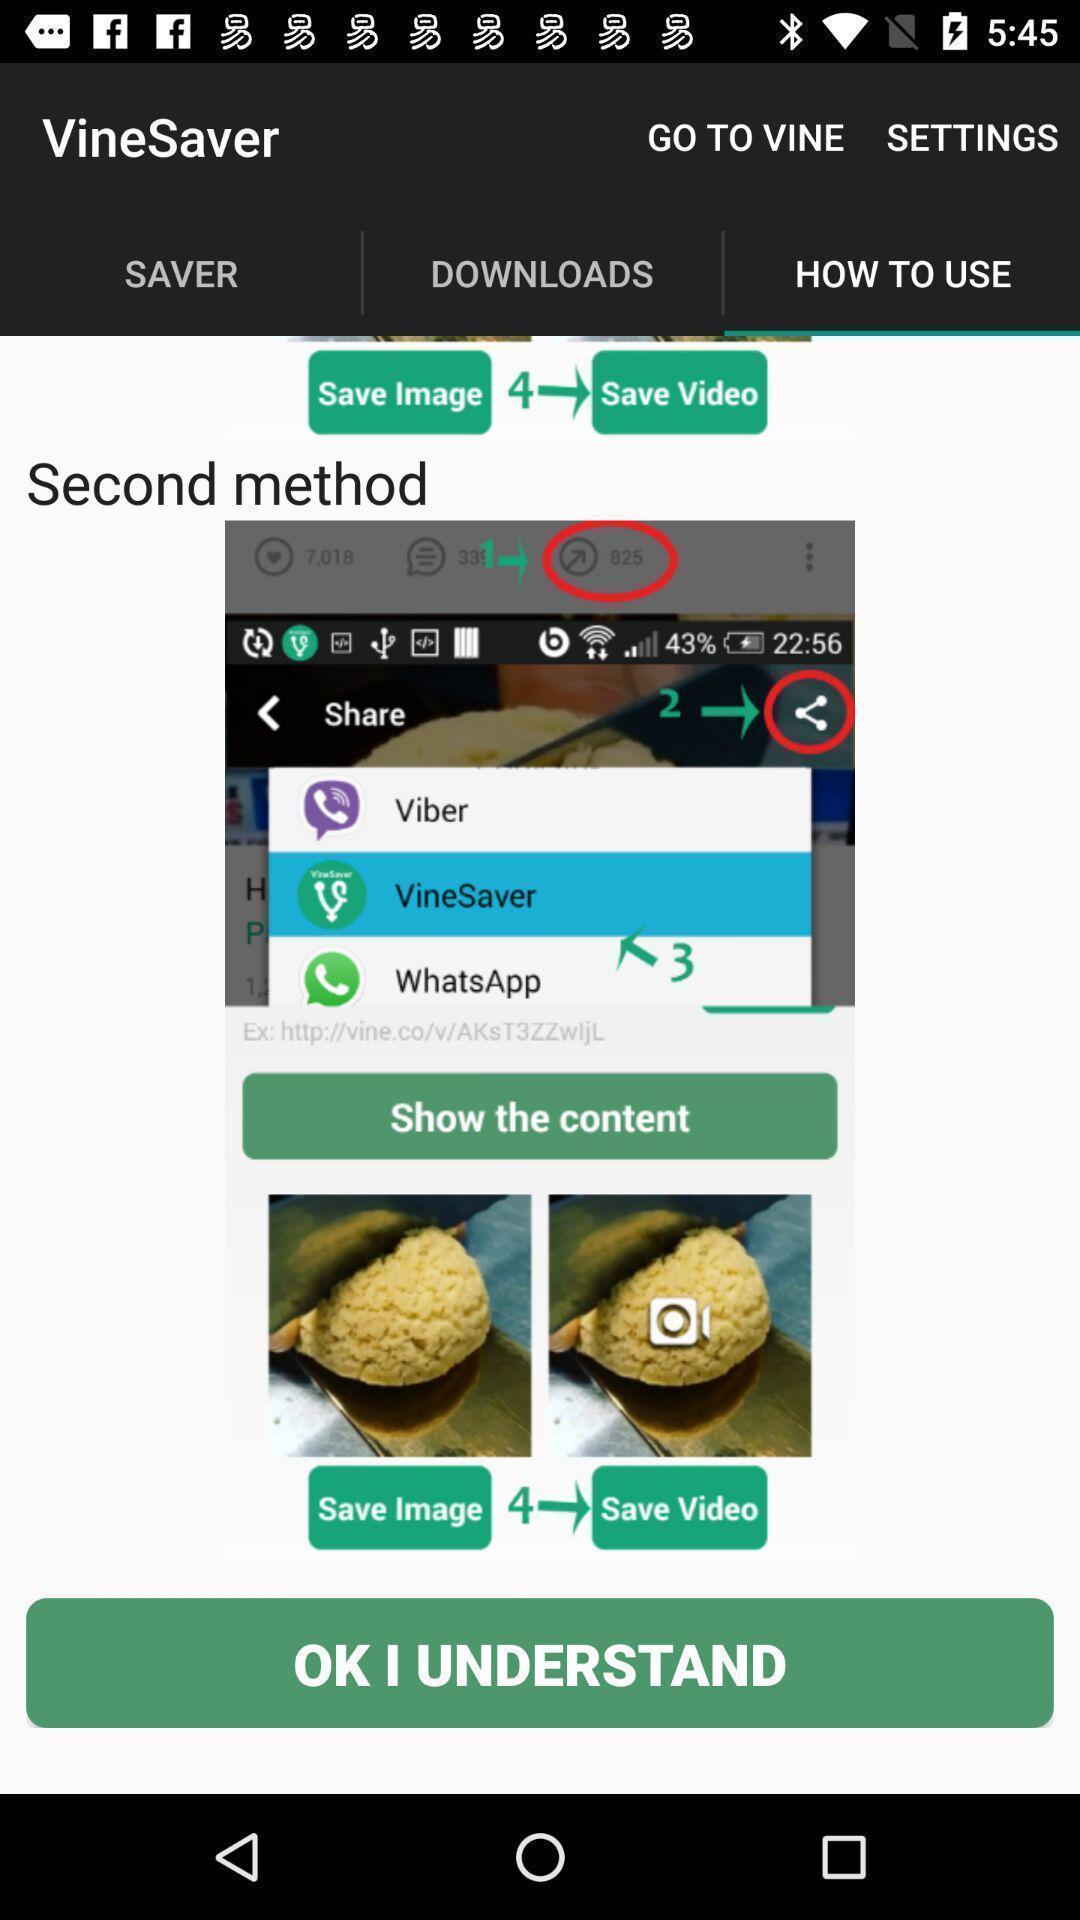Summarize the main components in this picture. Page showing methods to save videos on an app. 